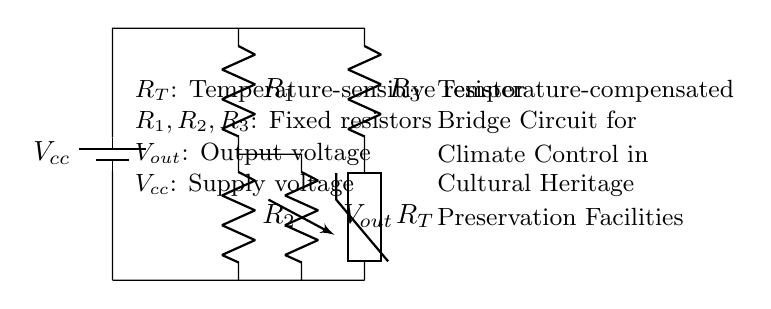What is the supply voltage in this circuit? The supply voltage is indicated by the battery symbol labeled as Vcc in the circuit diagram, which provides the necessary voltage for operation.
Answer: Vcc What component is temperature-sensitive in this circuit? The component labeled as R_T represents the thermistor, which is a temperature-sensitive resistor used to detect changes in temperature in the circuit.
Answer: R_T What type of bridge configuration is employed in this circuit? This circuit uses a Wheatstone bridge configuration, which consists of resistors arranged to measure unknown resistances based on the balance between two voltage dividers.
Answer: Wheatstone bridge What is the purpose of the fixed resistors R1, R2, and R3 in this circuit? R1, R2, and R3 serve as reference resistors that stabilize the bridge and allow for a precise measurement of the output voltage based on the resistance of the thermistor R_T.
Answer: Stabilization How does the output voltage relate to temperature changes in this circuit? The output voltage V_out changes as the resistance of the thermistor R_T varies with temperature, allowing the circuit to provide a measurable signal that corresponds to temperature fluctuations.
Answer: Measurable signal What is the output voltage of this circuit derived from? The output voltage V_out is derived from the voltage difference created by the balance of the resistances in the bridge configuration, indicating the impact of the temperature-sensitive resistor R_T.
Answer: Voltage difference 